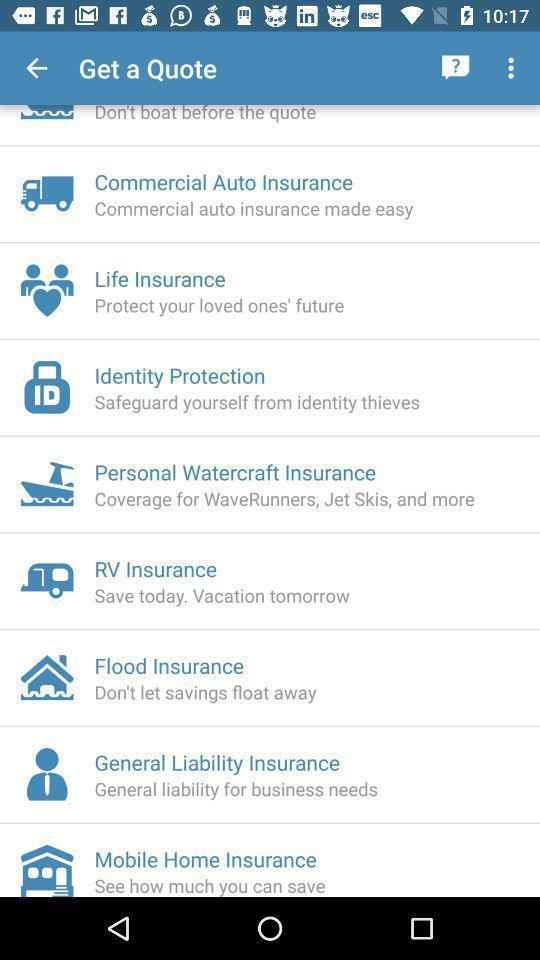Tell me what you see in this picture. Various options displayed of an insurance app. 